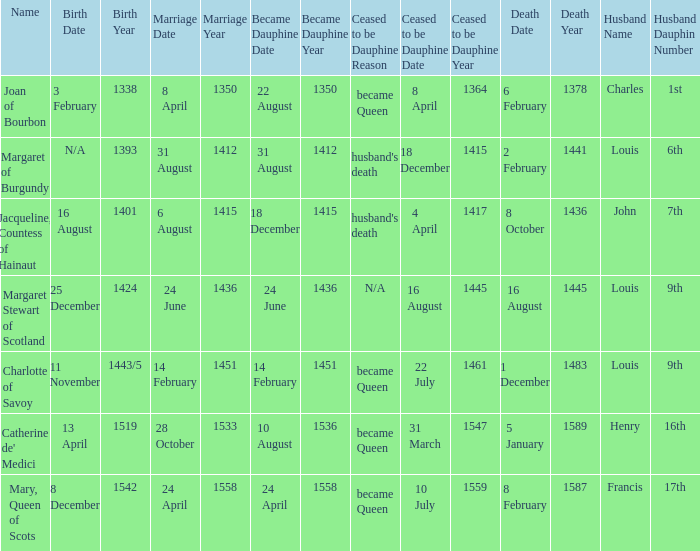When was the death of the person with husband charles, 1st dauphin? 6 February 1378. 